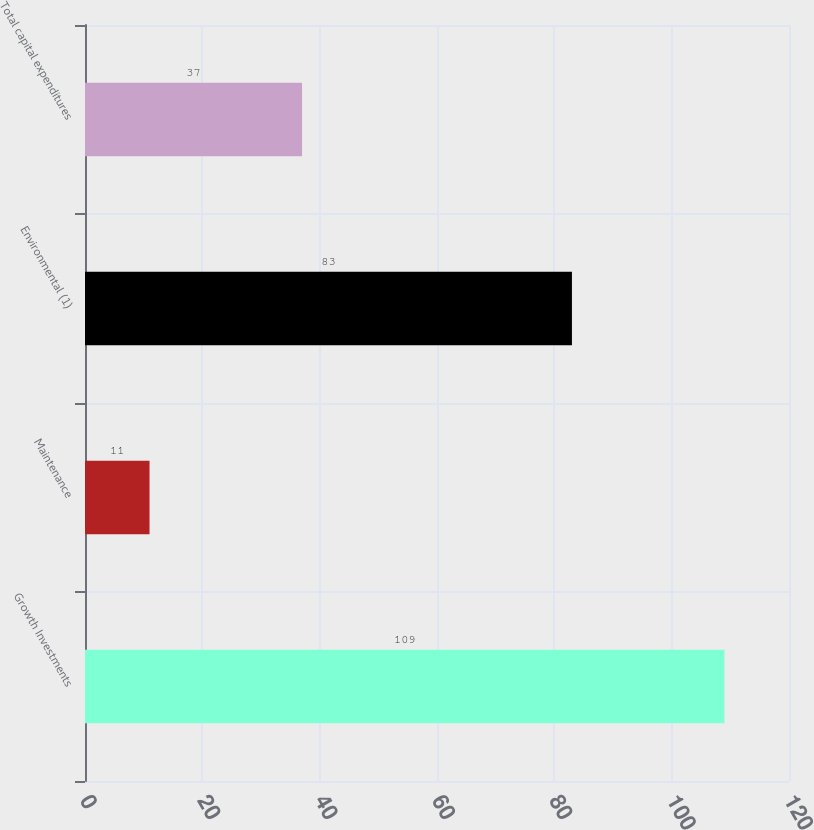<chart> <loc_0><loc_0><loc_500><loc_500><bar_chart><fcel>Growth Investments<fcel>Maintenance<fcel>Environmental (1)<fcel>Total capital expenditures<nl><fcel>109<fcel>11<fcel>83<fcel>37<nl></chart> 